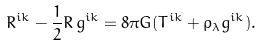Convert formula to latex. <formula><loc_0><loc_0><loc_500><loc_500>R ^ { i k } - \frac { 1 } { 2 } R \, g ^ { i k } = 8 \pi G ( T ^ { i k } + \rho _ { \lambda } g ^ { i k } ) .</formula> 